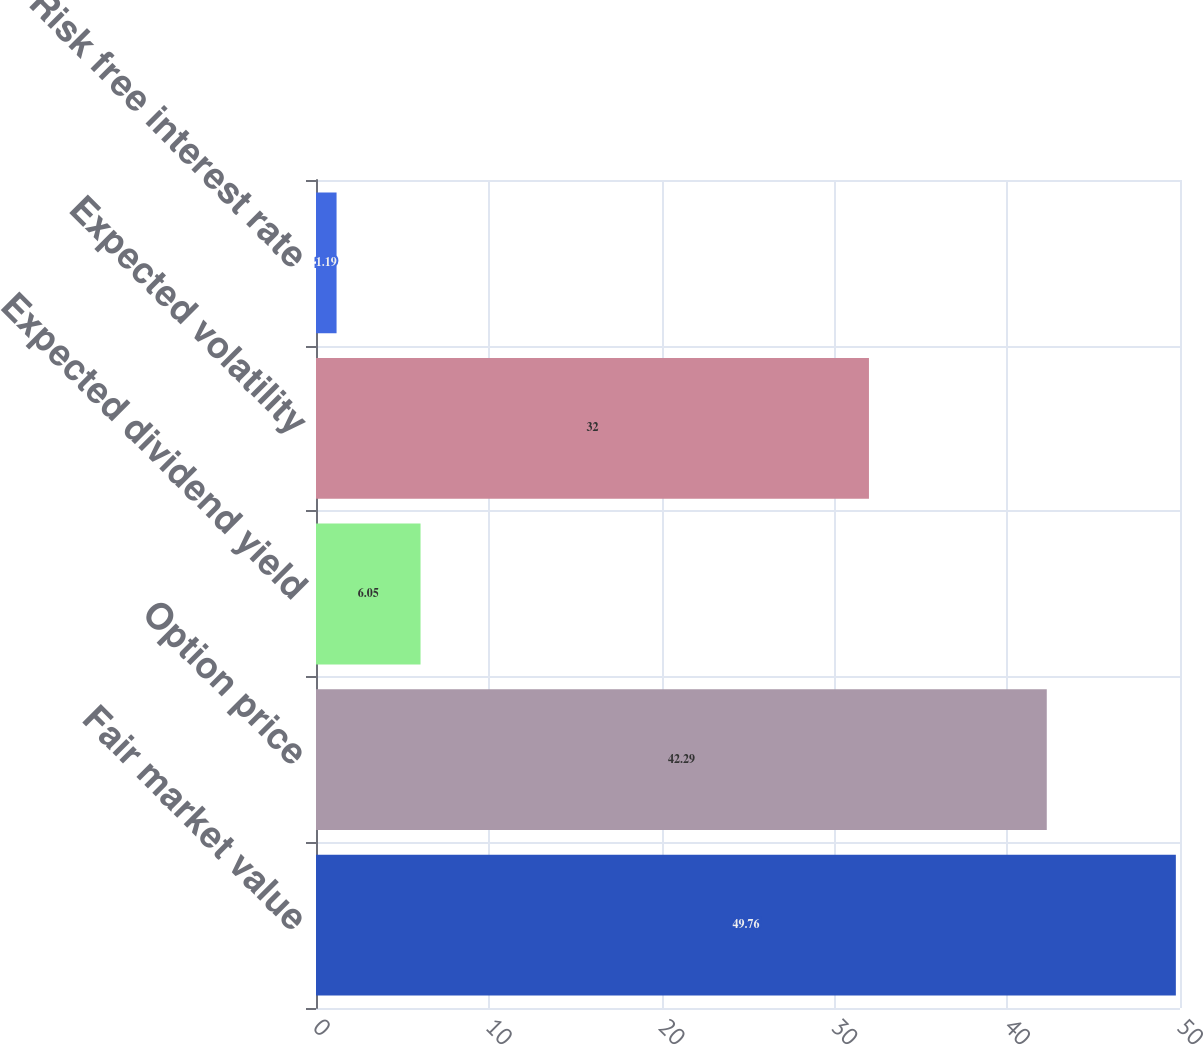<chart> <loc_0><loc_0><loc_500><loc_500><bar_chart><fcel>Fair market value<fcel>Option price<fcel>Expected dividend yield<fcel>Expected volatility<fcel>Risk free interest rate<nl><fcel>49.76<fcel>42.29<fcel>6.05<fcel>32<fcel>1.19<nl></chart> 